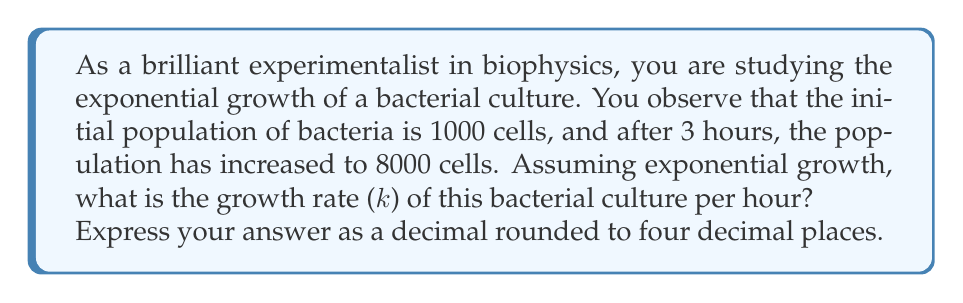Can you answer this question? To solve this problem, we'll use the exponential growth formula:

$$N(t) = N_0 \cdot e^{kt}$$

Where:
$N(t)$ is the population at time $t$
$N_0$ is the initial population
$k$ is the growth rate
$t$ is the time elapsed

We know:
$N_0 = 1000$ cells
$N(3) = 8000$ cells
$t = 3$ hours

Let's substitute these values into the formula:

$$8000 = 1000 \cdot e^{k \cdot 3}$$

Now, let's solve for $k$:

1) Divide both sides by 1000:
   $$8 = e^{3k}$$

2) Take the natural logarithm of both sides:
   $$\ln(8) = \ln(e^{3k})$$

3) Simplify the right side using the logarithm property $\ln(e^x) = x$:
   $$\ln(8) = 3k$$

4) Divide both sides by 3:
   $$\frac{\ln(8)}{3} = k$$

5) Calculate the value:
   $$k = \frac{\ln(8)}{3} \approx 0.6931$$

Rounding to four decimal places, we get 0.6931.
Answer: 0.6931 